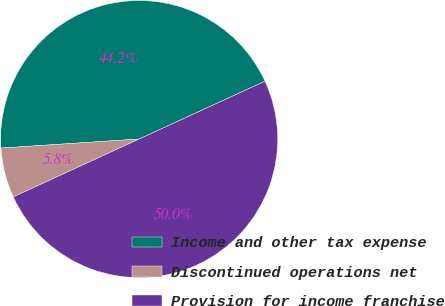<chart> <loc_0><loc_0><loc_500><loc_500><pie_chart><fcel>Income and other tax expense<fcel>Discontinued operations net<fcel>Provision for income franchise<nl><fcel>44.18%<fcel>5.82%<fcel>50.0%<nl></chart> 